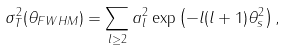<formula> <loc_0><loc_0><loc_500><loc_500>\sigma _ { T } ^ { 2 } ( \theta _ { F W H M } ) = \sum _ { l \geq 2 } a _ { l } ^ { 2 } \exp \left ( - l ( l + 1 ) \theta _ { s } ^ { 2 } \right ) ,</formula> 